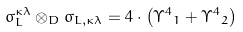Convert formula to latex. <formula><loc_0><loc_0><loc_500><loc_500>\sigma _ { L } ^ { \kappa \lambda } \otimes _ { D } \sigma _ { L , \kappa \lambda } = 4 \cdot \left ( { \Upsilon ^ { 4 } } _ { 1 } + { \Upsilon ^ { 4 } } _ { 2 } \right )</formula> 